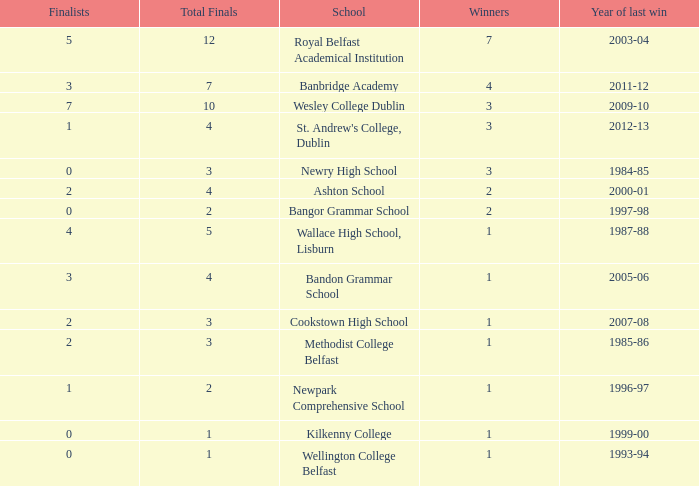What the name of  the school where the last win in 2007-08? Cookstown High School. 